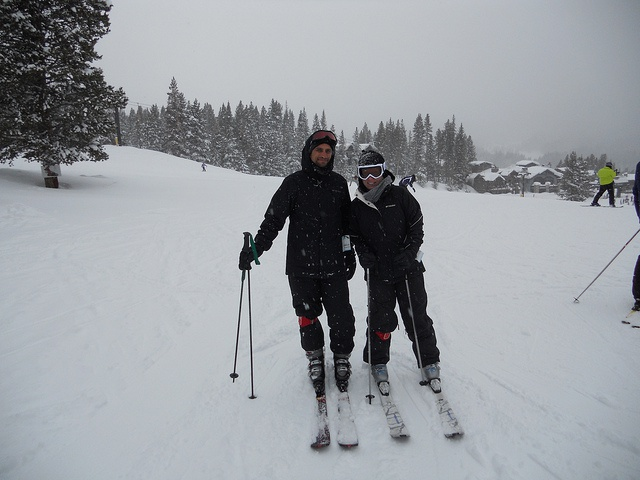Describe the objects in this image and their specific colors. I can see people in black, gray, darkgray, and lightgray tones, people in black, gray, darkgray, and lightgray tones, skis in black, darkgray, and gray tones, skis in black, darkgray, gray, and maroon tones, and people in black, darkgray, navy, and gray tones in this image. 